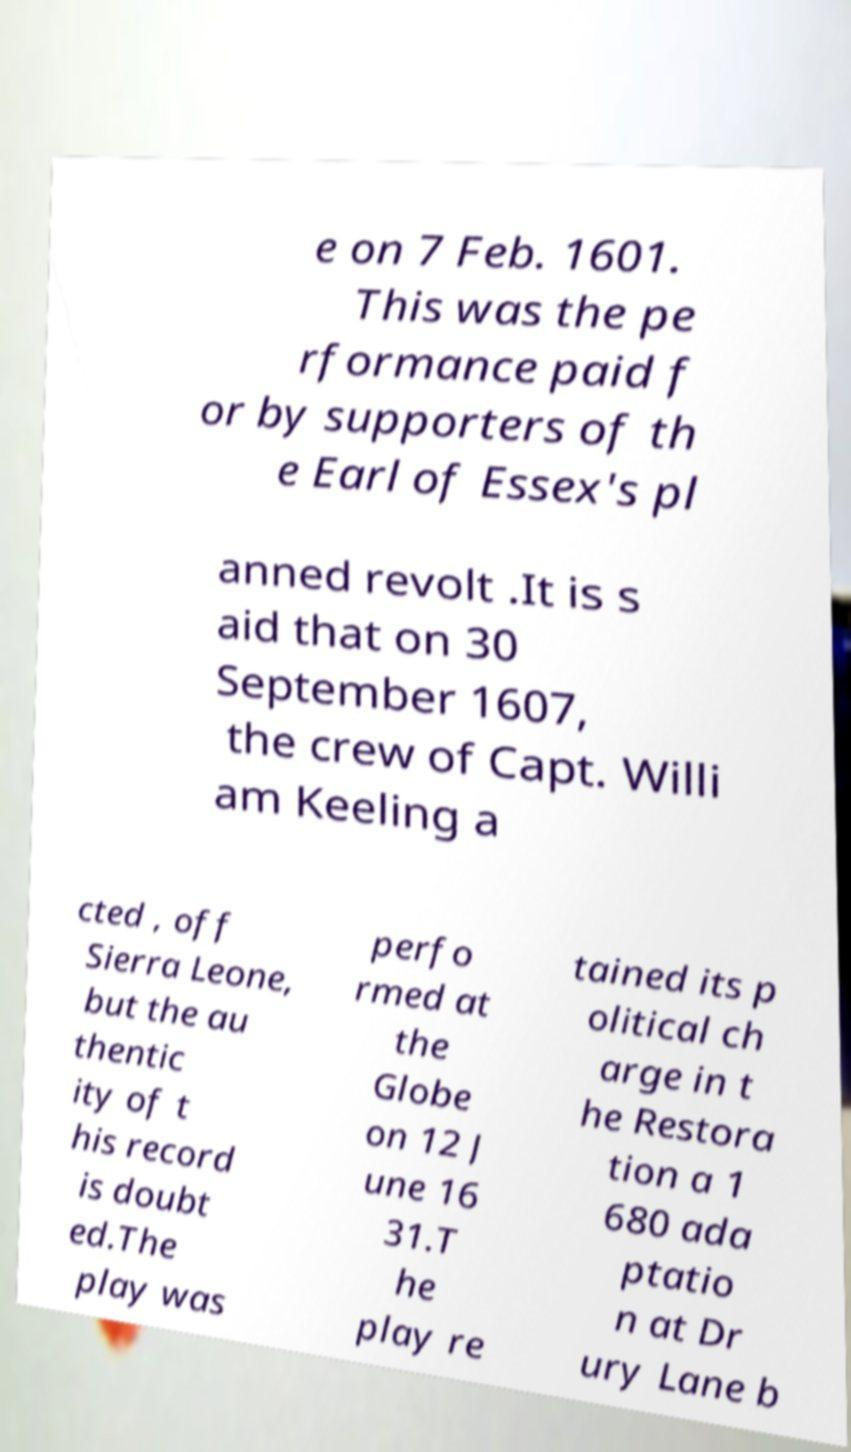Can you read and provide the text displayed in the image?This photo seems to have some interesting text. Can you extract and type it out for me? e on 7 Feb. 1601. This was the pe rformance paid f or by supporters of th e Earl of Essex's pl anned revolt .It is s aid that on 30 September 1607, the crew of Capt. Willi am Keeling a cted , off Sierra Leone, but the au thentic ity of t his record is doubt ed.The play was perfo rmed at the Globe on 12 J une 16 31.T he play re tained its p olitical ch arge in t he Restora tion a 1 680 ada ptatio n at Dr ury Lane b 